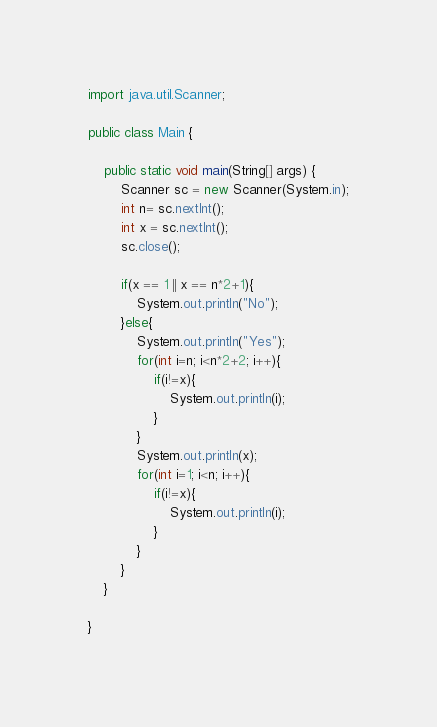Convert code to text. <code><loc_0><loc_0><loc_500><loc_500><_Java_>import java.util.Scanner;

public class Main {

	public static void main(String[] args) {
		Scanner sc = new Scanner(System.in);
		int n= sc.nextInt();
		int x = sc.nextInt();
		sc.close();
		
		if(x == 1 || x == n*2+1){
			System.out.println("No");
		}else{
			System.out.println("Yes");
			for(int i=n; i<n*2+2; i++){
				if(i!=x){
					System.out.println(i);
				}
			}
			System.out.println(x);
			for(int i=1; i<n; i++){
				if(i!=x){
					System.out.println(i);
				}
			}
		}
	}

}</code> 